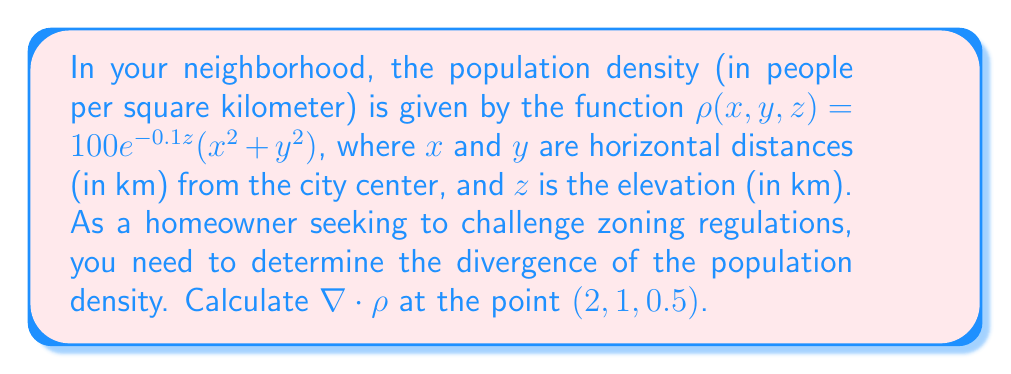Could you help me with this problem? To find the divergence of the population density, we need to calculate $\nabla \cdot \rho$. The divergence in 3D Cartesian coordinates is given by:

$$\nabla \cdot \rho = \frac{\partial \rho}{\partial x} + \frac{\partial \rho}{\partial y} + \frac{\partial \rho}{\partial z}$$

Let's calculate each partial derivative:

1) $\frac{\partial \rho}{\partial x}$:
   $$\frac{\partial \rho}{\partial x} = 100e^{-0.1z} \cdot 2x$$

2) $\frac{\partial \rho}{\partial y}$:
   $$\frac{\partial \rho}{\partial y} = 100e^{-0.1z} \cdot 2y$$

3) $\frac{\partial \rho}{\partial z}$:
   $$\frac{\partial \rho}{\partial z} = 100e^{-0.1z}(x^2 + y^2) \cdot (-0.1)$$

Now, we can substitute these into the divergence formula:

$$\nabla \cdot \rho = 100e^{-0.1z}(2x + 2y - 0.1(x^2 + y^2))$$

Evaluating at the point $(2, 1, 0.5)$:

$$\begin{align*}
\nabla \cdot \rho &= 100e^{-0.1(0.5)}(2(2) + 2(1) - 0.1((2)^2 + (1)^2)) \\
&= 100e^{-0.05}(4 + 2 - 0.1(5)) \\
&= 100e^{-0.05}(6 - 0.5) \\
&= 100e^{-0.05}(5.5) \\
&\approx 522.88
\end{align*}$$
Answer: $522.88$ people/km³ 